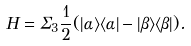Convert formula to latex. <formula><loc_0><loc_0><loc_500><loc_500>H = \Sigma _ { 3 } \frac { 1 } { 2 } ( | \alpha \rangle \langle \alpha | - | \beta \rangle \langle \beta | ) .</formula> 